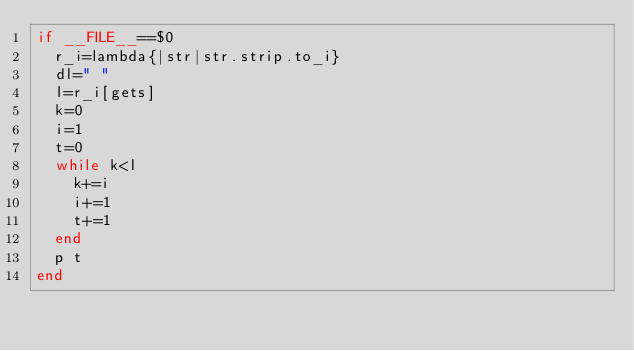Convert code to text. <code><loc_0><loc_0><loc_500><loc_500><_Ruby_>if __FILE__==$0
	r_i=lambda{|str|str.strip.to_i}
	dl=" "
	l=r_i[gets]
	k=0
	i=1
	t=0
	while k<l
		k+=i
		i+=1
		t+=1
	end
	p t
end</code> 